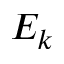Convert formula to latex. <formula><loc_0><loc_0><loc_500><loc_500>E _ { k }</formula> 